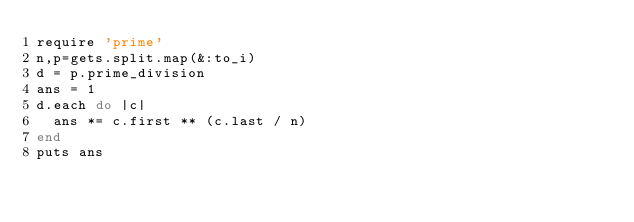<code> <loc_0><loc_0><loc_500><loc_500><_Ruby_>require 'prime'
n,p=gets.split.map(&:to_i)
d = p.prime_division
ans = 1
d.each do |c|
  ans *= c.first ** (c.last / n)
end
puts ans
</code> 